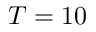Convert formula to latex. <formula><loc_0><loc_0><loc_500><loc_500>T = 1 0</formula> 